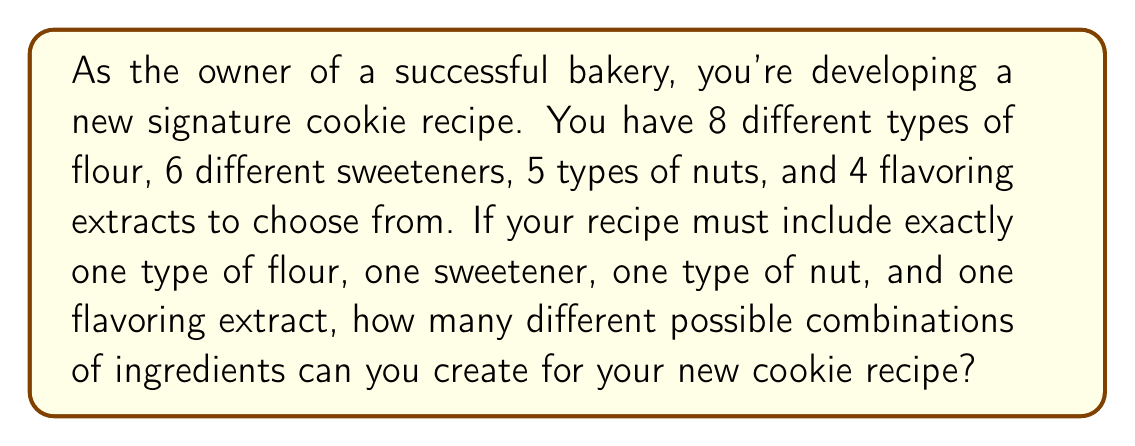Help me with this question. Let's approach this step-by-step using the multiplication principle of counting:

1) For each component of the recipe, we're selecting one item from a set of options:
   - 1 flour from 8 options
   - 1 sweetener from 6 options
   - 1 type of nut from 5 options
   - 1 flavoring extract from 4 options

2) The multiplication principle states that if we have a series of choices, where:
   - There are $m$ ways of doing something,
   - $n$ ways of doing another thing,
   - $p$ ways of doing a third thing, and so on,
   Then there are $m \times n \times p \times ...$ ways to do the entire series of things.

3) In this case, we have:
   - 8 ways to choose the flour
   - 6 ways to choose the sweetener
   - 5 ways to choose the nut
   - 4 ways to choose the flavoring extract

4) Therefore, the total number of possible combinations is:

   $$ 8 \times 6 \times 5 \times 4 = 960 $$

This means you can create 960 different combinations of ingredients for your new cookie recipe, giving you plenty of options to experiment with before settling on your new signature cookie.
Answer: 960 possible combinations 